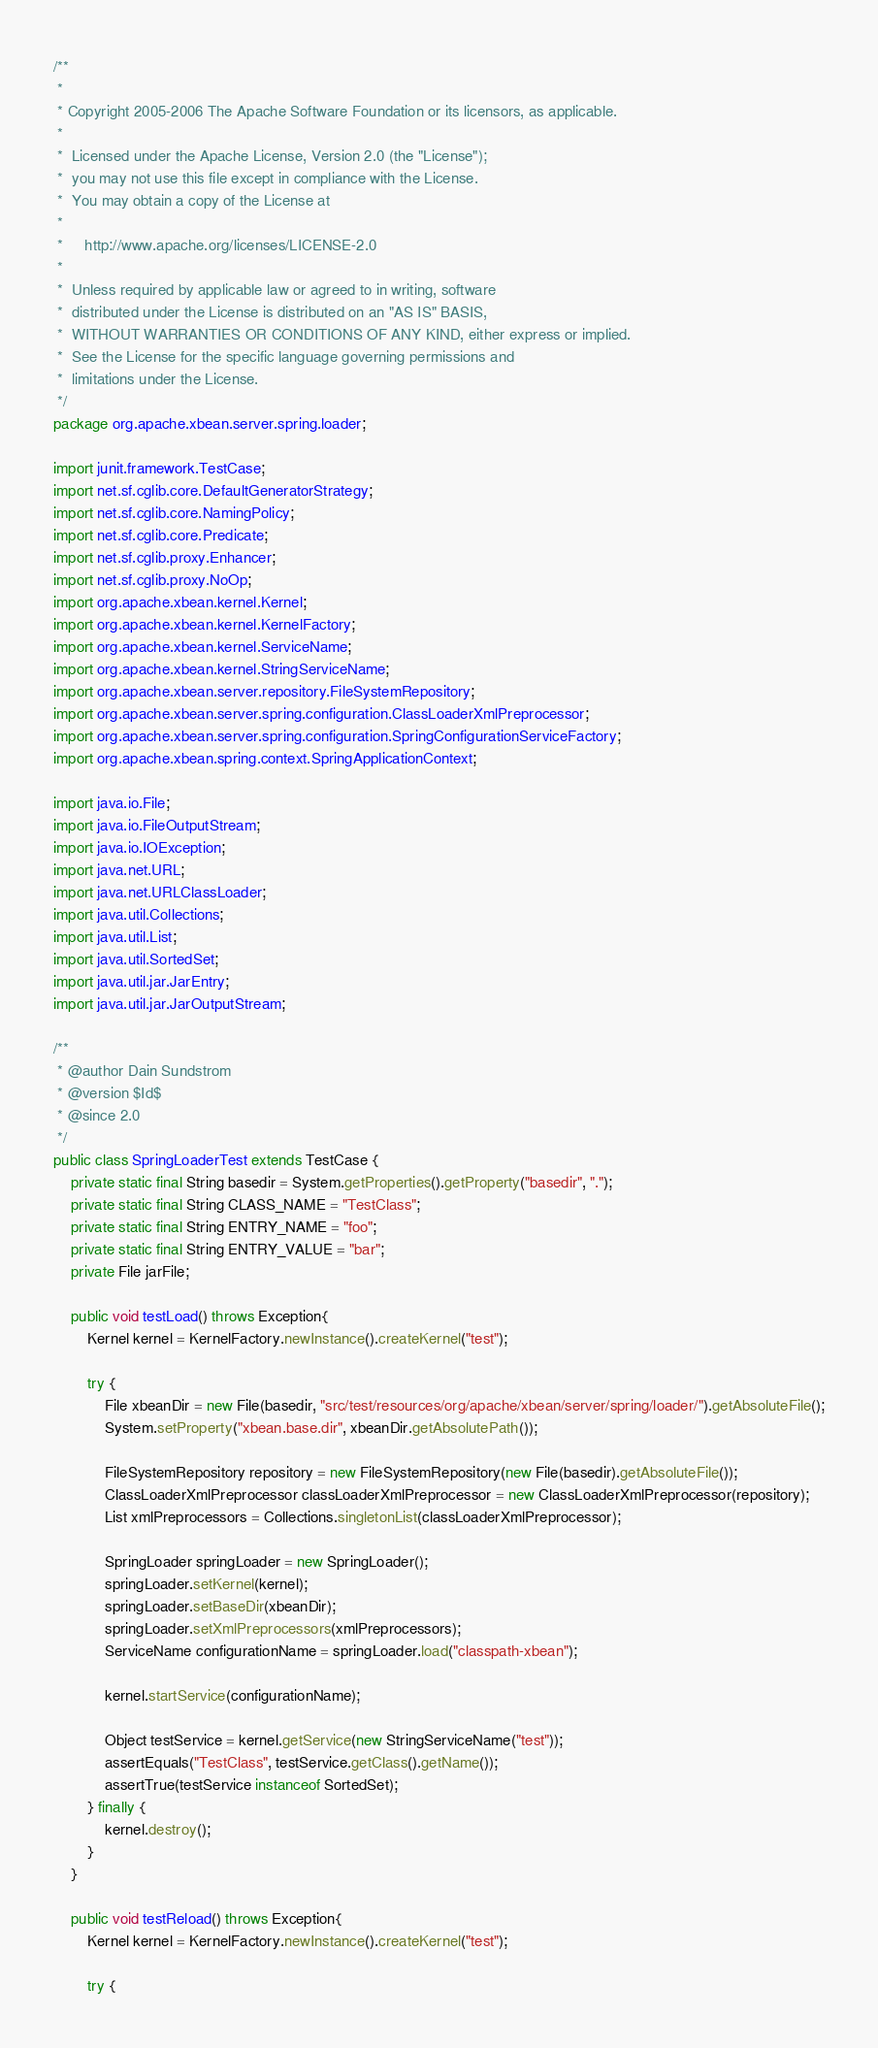Convert code to text. <code><loc_0><loc_0><loc_500><loc_500><_Java_>/**
 *
 * Copyright 2005-2006 The Apache Software Foundation or its licensors, as applicable.
 *
 *  Licensed under the Apache License, Version 2.0 (the "License");
 *  you may not use this file except in compliance with the License.
 *  You may obtain a copy of the License at
 *
 *     http://www.apache.org/licenses/LICENSE-2.0
 *
 *  Unless required by applicable law or agreed to in writing, software
 *  distributed under the License is distributed on an "AS IS" BASIS,
 *  WITHOUT WARRANTIES OR CONDITIONS OF ANY KIND, either express or implied.
 *  See the License for the specific language governing permissions and
 *  limitations under the License.
 */
package org.apache.xbean.server.spring.loader;

import junit.framework.TestCase;
import net.sf.cglib.core.DefaultGeneratorStrategy;
import net.sf.cglib.core.NamingPolicy;
import net.sf.cglib.core.Predicate;
import net.sf.cglib.proxy.Enhancer;
import net.sf.cglib.proxy.NoOp;
import org.apache.xbean.kernel.Kernel;
import org.apache.xbean.kernel.KernelFactory;
import org.apache.xbean.kernel.ServiceName;
import org.apache.xbean.kernel.StringServiceName;
import org.apache.xbean.server.repository.FileSystemRepository;
import org.apache.xbean.server.spring.configuration.ClassLoaderXmlPreprocessor;
import org.apache.xbean.server.spring.configuration.SpringConfigurationServiceFactory;
import org.apache.xbean.spring.context.SpringApplicationContext;

import java.io.File;
import java.io.FileOutputStream;
import java.io.IOException;
import java.net.URL;
import java.net.URLClassLoader;
import java.util.Collections;
import java.util.List;
import java.util.SortedSet;
import java.util.jar.JarEntry;
import java.util.jar.JarOutputStream;

/**
 * @author Dain Sundstrom
 * @version $Id$
 * @since 2.0
 */
public class SpringLoaderTest extends TestCase {
    private static final String basedir = System.getProperties().getProperty("basedir", ".");
    private static final String CLASS_NAME = "TestClass";
    private static final String ENTRY_NAME = "foo";
    private static final String ENTRY_VALUE = "bar";
    private File jarFile;

    public void testLoad() throws Exception{
        Kernel kernel = KernelFactory.newInstance().createKernel("test");

        try {
            File xbeanDir = new File(basedir, "src/test/resources/org/apache/xbean/server/spring/loader/").getAbsoluteFile();
            System.setProperty("xbean.base.dir", xbeanDir.getAbsolutePath());

            FileSystemRepository repository = new FileSystemRepository(new File(basedir).getAbsoluteFile());
            ClassLoaderXmlPreprocessor classLoaderXmlPreprocessor = new ClassLoaderXmlPreprocessor(repository);
            List xmlPreprocessors = Collections.singletonList(classLoaderXmlPreprocessor);

            SpringLoader springLoader = new SpringLoader();
            springLoader.setKernel(kernel);
            springLoader.setBaseDir(xbeanDir);
            springLoader.setXmlPreprocessors(xmlPreprocessors);
            ServiceName configurationName = springLoader.load("classpath-xbean");

            kernel.startService(configurationName);

            Object testService = kernel.getService(new StringServiceName("test"));
            assertEquals("TestClass", testService.getClass().getName());
            assertTrue(testService instanceof SortedSet);
        } finally {
            kernel.destroy();
        }
    }

    public void testReload() throws Exception{
        Kernel kernel = KernelFactory.newInstance().createKernel("test");

        try {</code> 